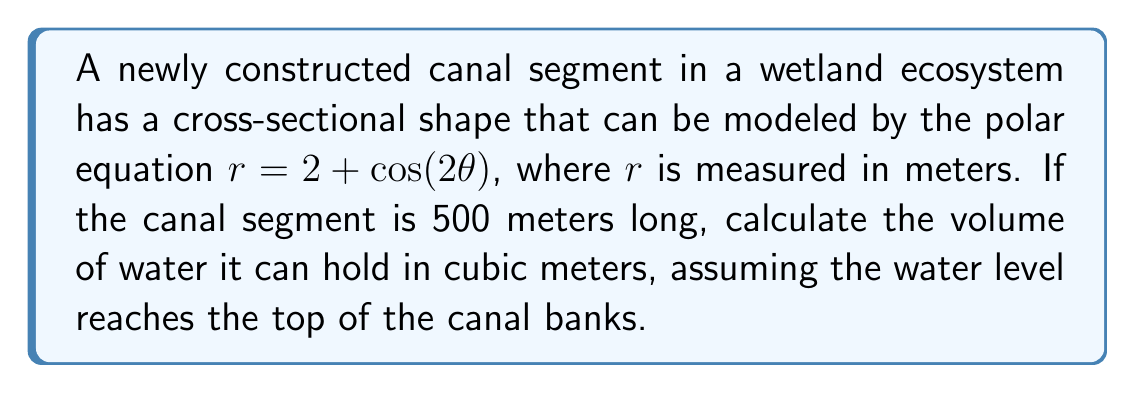Provide a solution to this math problem. To solve this problem, we'll follow these steps:

1) The volume of the canal segment can be calculated by integrating the cross-sectional area over the length of the segment.

2) In polar coordinates, the area of a region is given by the formula:

   $$ A = \frac{1}{2} \int_0^{2\pi} r^2 d\theta $$

3) Our polar equation is $r = 2 + \cos(2\theta)$. We need to square this:

   $$ r^2 = (2 + \cos(2\theta))^2 = 4 + 4\cos(2\theta) + \cos^2(2\theta) $$

4) Now, we can set up our integral:

   $$ A = \frac{1}{2} \int_0^{2\pi} (4 + 4\cos(2\theta) + \cos^2(2\theta)) d\theta $$

5) Let's integrate each term:
   
   - $\int_0^{2\pi} 4 d\theta = 4\theta |_0^{2\pi} = 8\pi$
   - $\int_0^{2\pi} 4\cos(2\theta) d\theta = 2\sin(2\theta) |_0^{2\pi} = 0$
   - $\int_0^{2\pi} \cos^2(2\theta) d\theta = \frac{\theta}{2} + \frac{\sin(4\theta)}{8} |_0^{2\pi} = \pi$

6) Adding these up:

   $$ A = \frac{1}{2} (8\pi + 0 + \pi) = \frac{9\pi}{2} $$

7) The area is in square meters. To get the volume, we multiply by the length of the canal segment:

   $$ V = A \cdot 500 = \frac{9\pi}{2} \cdot 500 = 2250\pi $$

Therefore, the volume of water the canal segment can hold is $2250\pi$ cubic meters.
Answer: $2250\pi$ cubic meters 